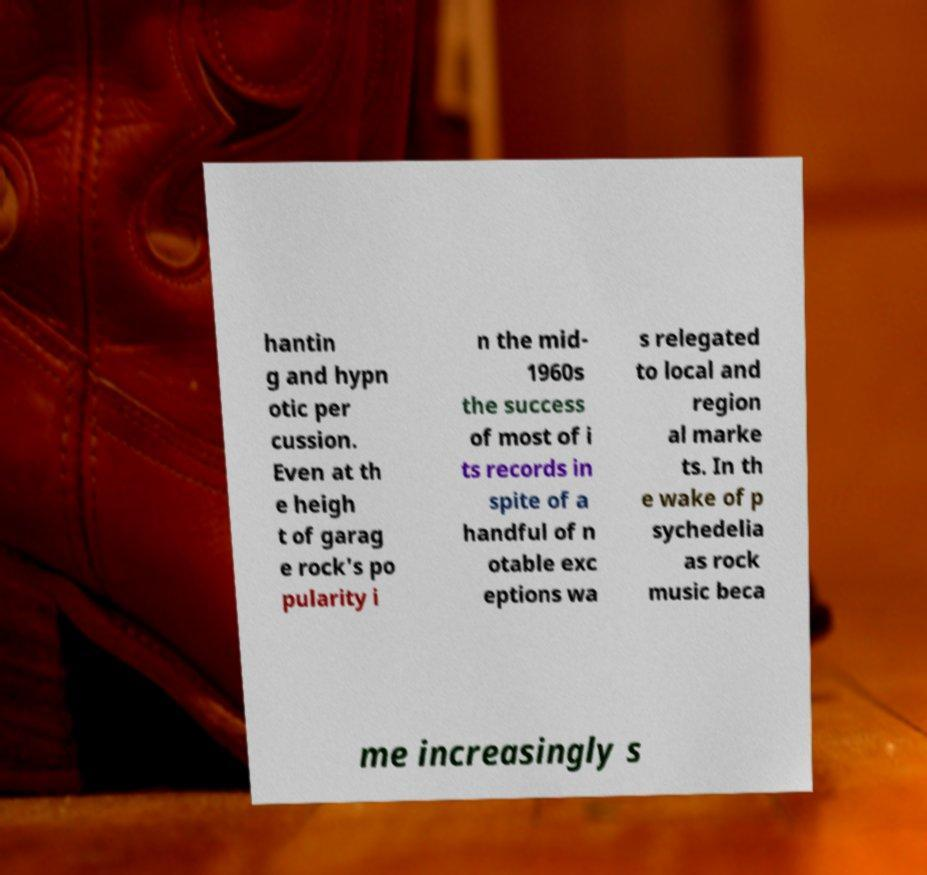Could you extract and type out the text from this image? hantin g and hypn otic per cussion. Even at th e heigh t of garag e rock's po pularity i n the mid- 1960s the success of most of i ts records in spite of a handful of n otable exc eptions wa s relegated to local and region al marke ts. In th e wake of p sychedelia as rock music beca me increasingly s 